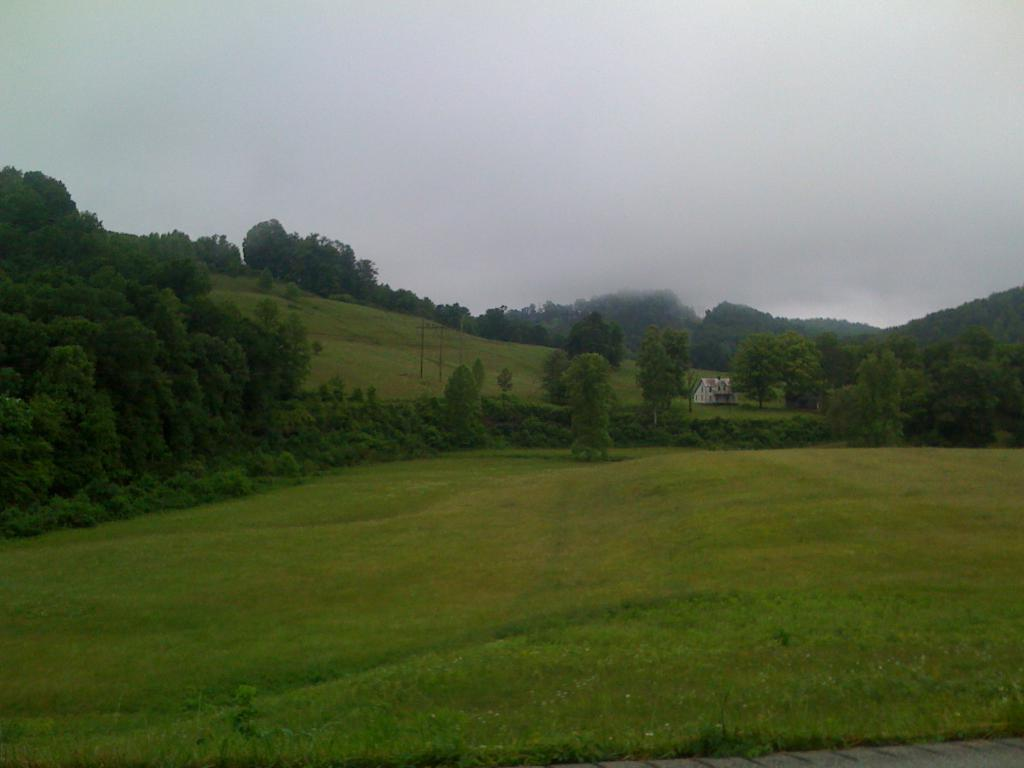What type of terrain is visible in the image? Ground and grass are visible in the image. What type of vegetation can be seen in the image? Plants and trees are visible in the image. What is visible in the background of the image? There is a building, trees, and the sky visible in the background of the image. What time is displayed on the clock in the image? There is no clock present in the image. Who is the expert in the field of botany in the image? There is no person or expert mentioned in the image. 